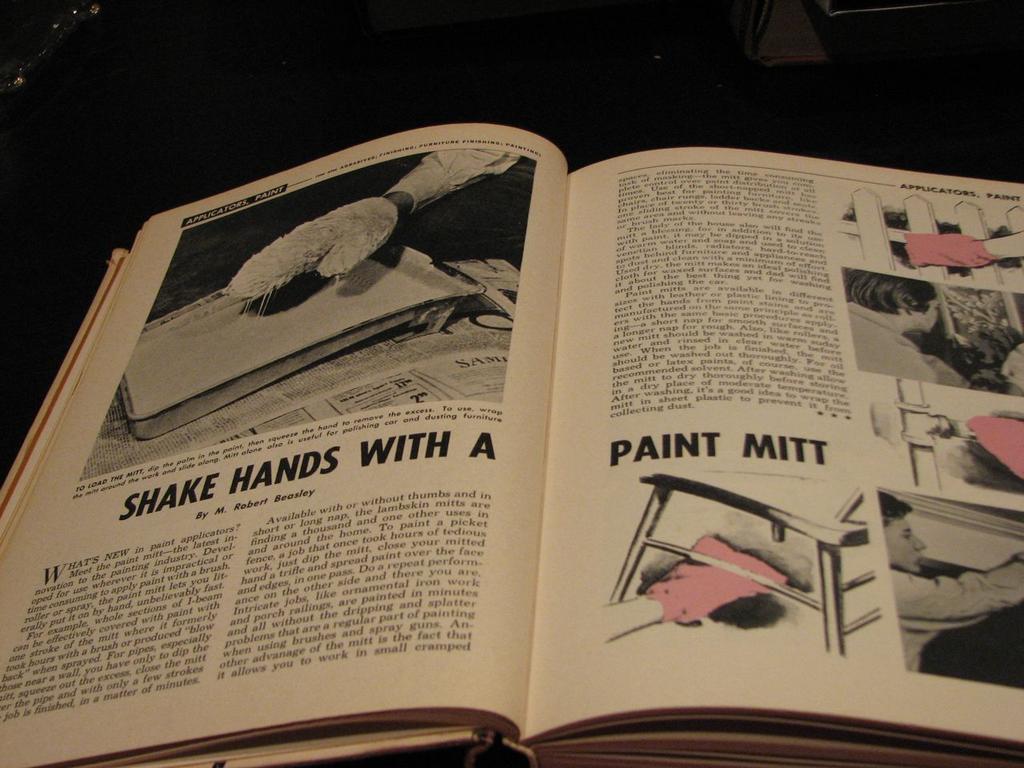What home improvement tool is this book describing?
Ensure brevity in your answer.  Paint mitt. Who wrote this article?
Offer a very short reply. Robert browley. 